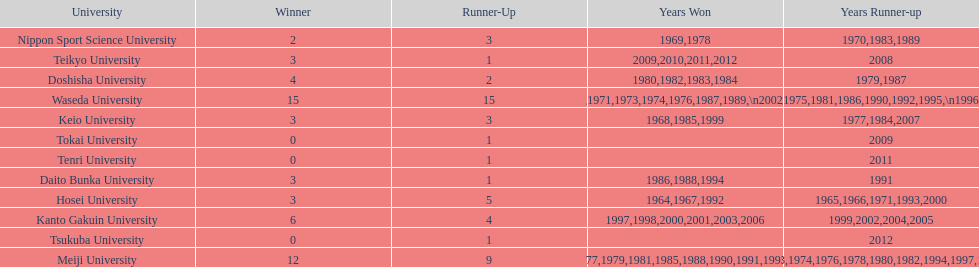Which university had the most years won? Waseda University. 